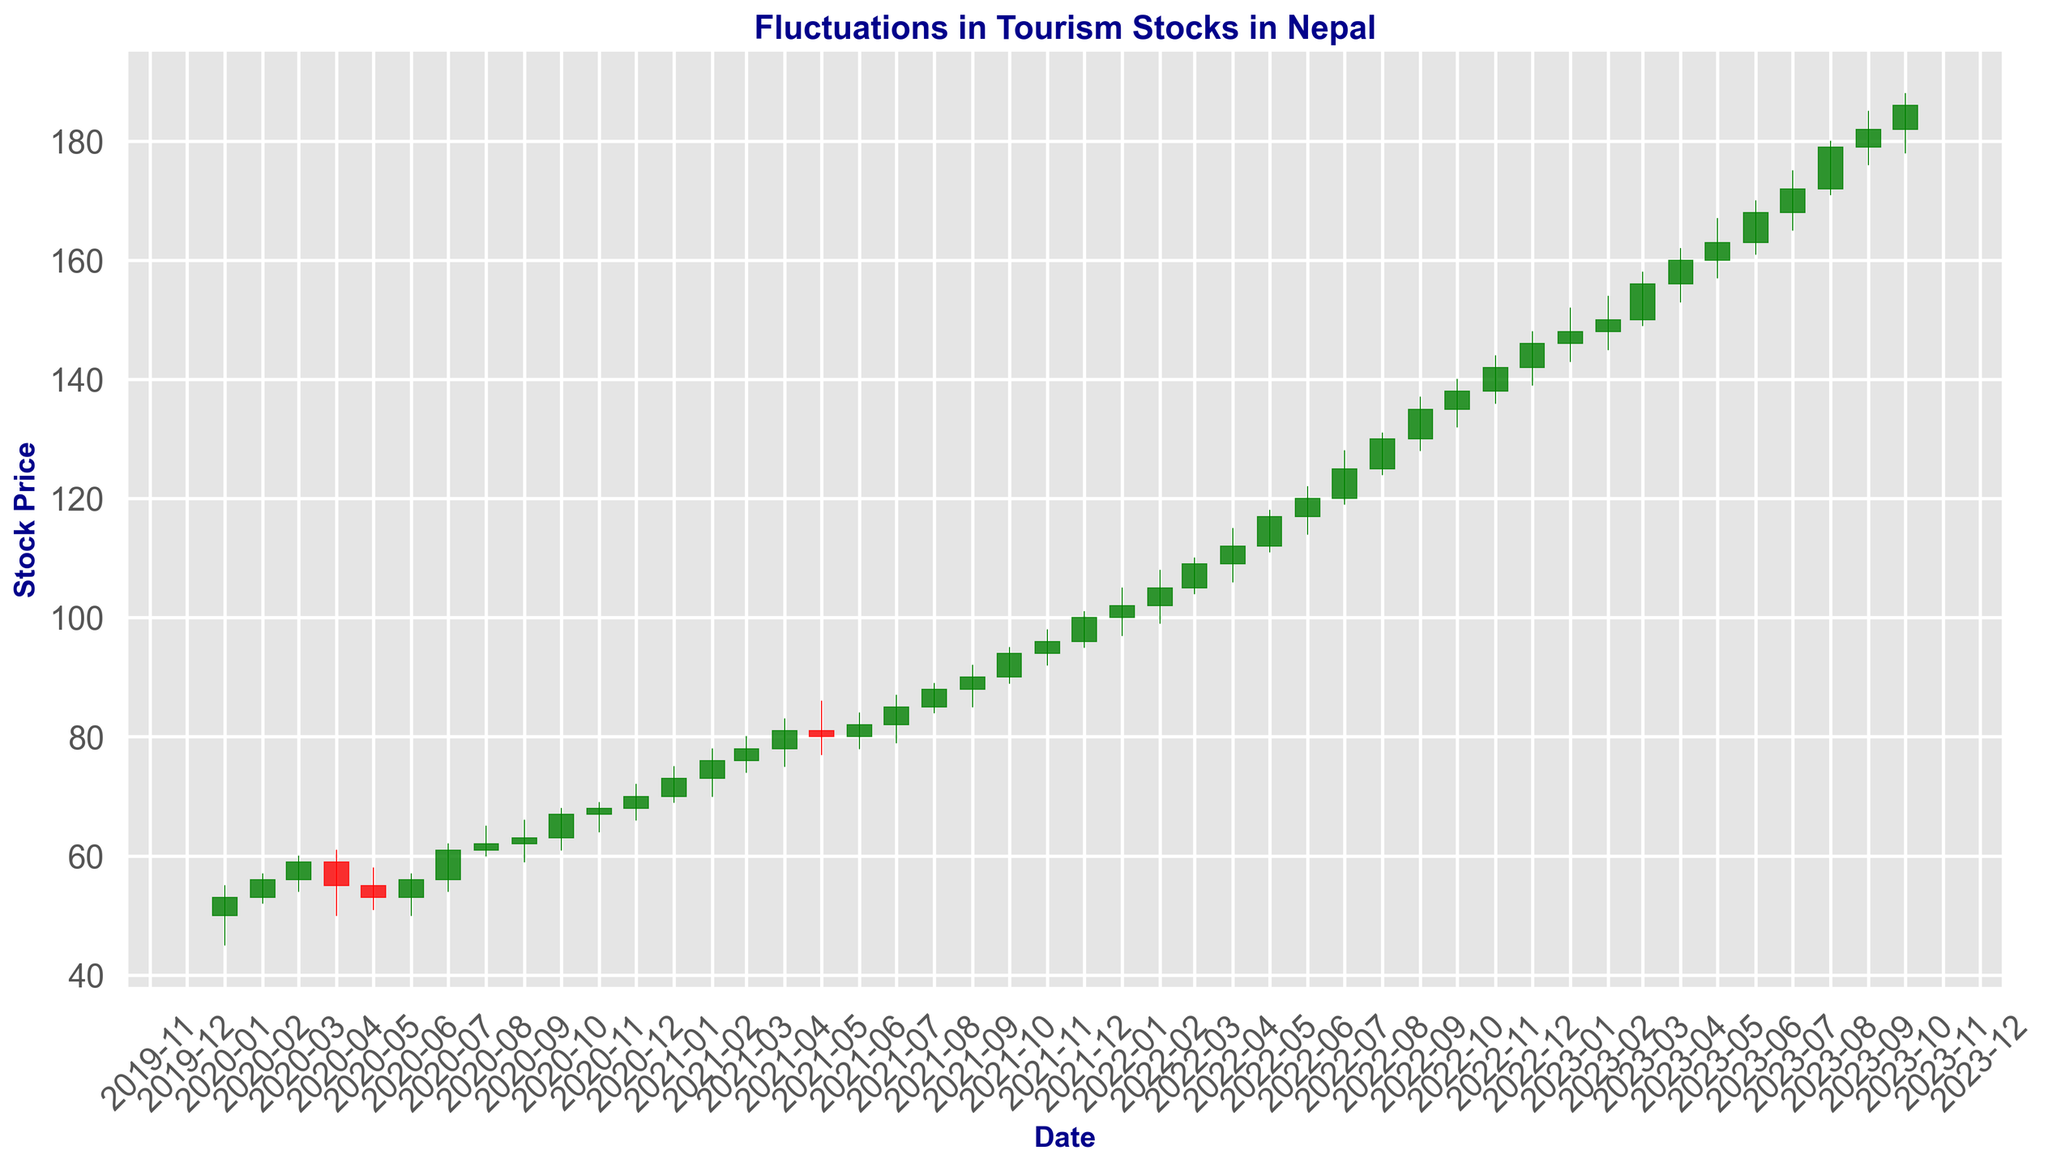Which months in 2020 show a decrease in the closing stock price compared to the previous month? The closing stock prices can be observed to decrease if the current month's closing price is less than the previous month's closing price. By comparing each month in 2020: January(53) < February(56) (no decrease), February(56) < March(59) (no decrease), March(59) > April(55) (decrease), April(55) > May(53) (decrease), May(53) < June(56) (no decrease), June(56) > July(61) (no decrease), July(61) < August(62) (no decrease), August(62) < September(63) (no decrease), September(63) < October(67) (no decrease), October(67) < November(68) (no decrease), November(68) < December(70) (no decrease)
Answer: April, May How many times did the stock price close higher than it opened in the first quarter of 2023? Check the opening and closing prices for January, February, and March 2023. January(148 > 146), February(150 > 148), March(156 > 150). This shows that stock price closed higher in all three months of the first quarter
Answer: 3 What was the trend in the closing stock prices from April 2022 to June 2022? By evaluating the closing prices in April (112), May (117), and June (120), we see an increasing trend month-over-month
Answer: Increasing Which month in 2022 had the highest trading volume? Compare the volumes for each month in 2022 and find the maximum value which occurs in December (71000)
Answer: December Identify a period where the stock experienced the sharpest increase in closing price. To determine the sharpest increase, compare the difference between closing prices month-over-month. Analyzing the periods, the largest difference can be seen between the end of June (168) and July (179) in 2023, which is an increase of 15 points
Answer: June 2023 to July 2023 What is the average closing price for the year 2021? To calculate the average, sum the closing prices for each month in 2021 and divide by the number of months. Sum of the closing prices: 70+73+76+78+81+80+82+85+88+90+94+96 = 993; Average = 993 / 12 = 82.75
Answer: 82.75 Which quarter in 2021 had the highest average closing stock price? Calculate the average closing price for each quarter by dividing the sum of the closing prices of the relevant three months by three. Q1: (73+76+78)/3 = 75.67, Q2: (81+80+82)/3 = 81, Q3: (85+88+90)/3 = 87.67, Q4: (94+96+100)/3 = 96.67. Compare the averages, Q4 has the highest
Answer: Q4 Which month shows the highest high price in the timeframe given? Search for the month with the highest high price from the data provided. The maximum high price is observed in April 2023 with a high of 162
Answer: April 2023 By how much did the closing stock price increase from January 2020 to October 2023? Find the closing prices for these months from the dataset, January 2020 (53) and October 2023 (186). Difference = 186 - 53 = 133
Answer: 133 What is the closing price trend pattern for the month of December for each year from 2020 to 2022? Observe the closing stock prices for December in each respective year: December 2020 (70), December 2021 (96), and December 2022 (146). The pattern noted is a consistent increase
Answer: Increasing 